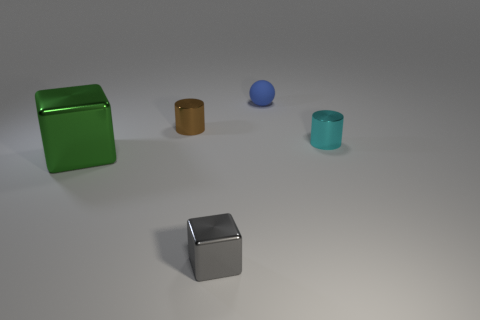Are there any other things that are made of the same material as the tiny blue sphere?
Make the answer very short. No. Is the number of green cubes in front of the big green object the same as the number of tiny spheres right of the small sphere?
Offer a terse response. Yes. There is a small shiny cylinder right of the tiny brown cylinder; is there a cylinder that is behind it?
Make the answer very short. Yes. The tiny blue thing has what shape?
Offer a very short reply. Sphere. There is a metal object that is left of the metal cylinder on the left side of the small gray cube; what size is it?
Give a very brief answer. Large. What is the size of the shiny object to the left of the small brown metal thing?
Your answer should be compact. Large. Are there fewer metallic objects that are in front of the large metallic thing than tiny things in front of the brown cylinder?
Keep it short and to the point. Yes. The rubber sphere has what color?
Keep it short and to the point. Blue. There is a shiny object right of the metal cube that is in front of the block that is to the left of the small brown shiny cylinder; what is its shape?
Offer a very short reply. Cylinder. There is a small cylinder that is right of the gray metallic cube; what material is it?
Your answer should be very brief. Metal. 